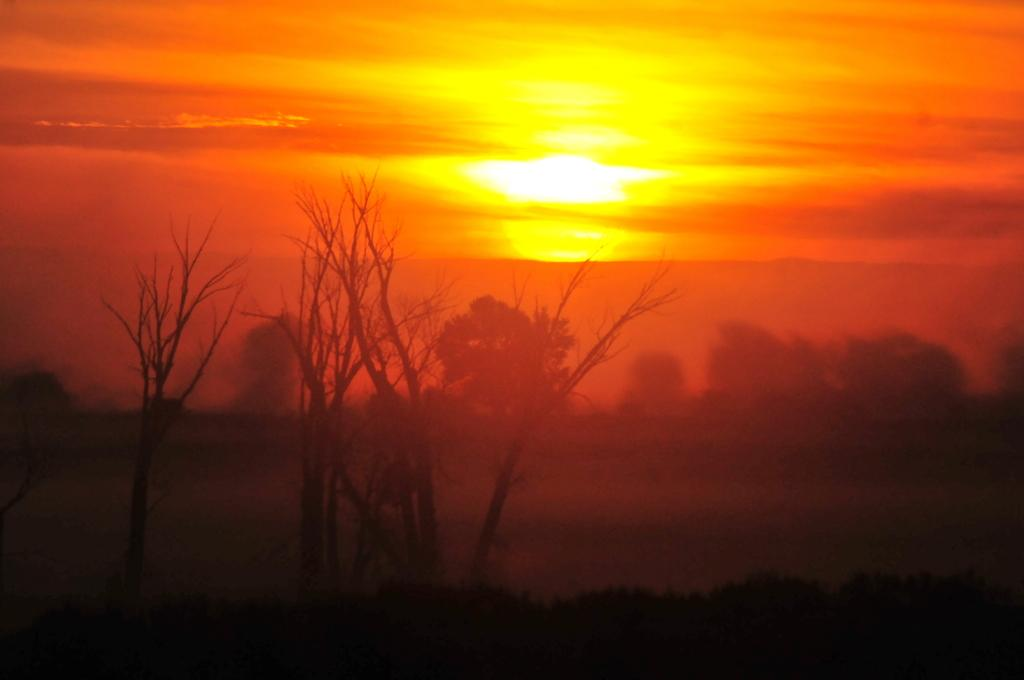What type of vegetation can be seen in the image? There are trees in the image. What is visible in the sky in the image? The sky is visible in the image, and the sun is observable. What is the overall color of the image? The image has an orange color. How many arms are visible in the image? There are no arms present in the image. What type of sack is being carried by the trees in the image? There are no sacks present in the image, as it features trees and a sky with the sun. 